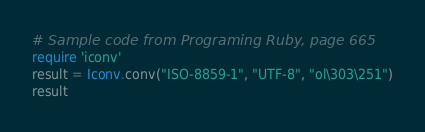<code> <loc_0><loc_0><loc_500><loc_500><_Ruby_># Sample code from Programing Ruby, page 665
require 'iconv'
result = Iconv.conv("ISO-8859-1", "UTF-8", "ol\303\251")
result
</code> 